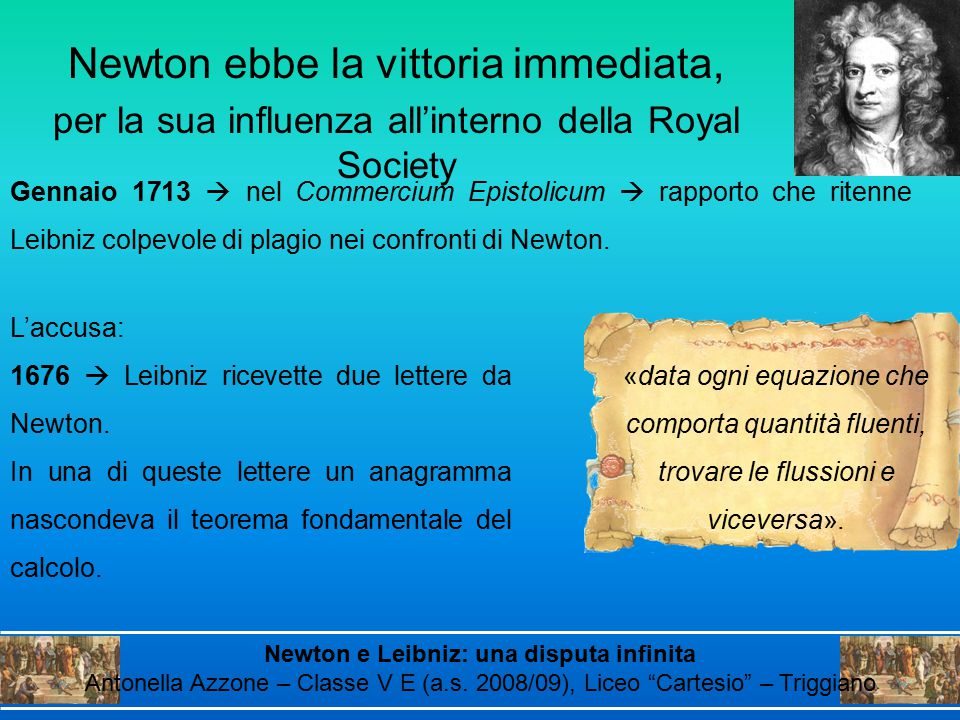What might be the historical significance of the anagram mentioned in the text, and how could it relate to the dispute between Newton and Leibniz? The anagram mentioned in the text holds significant historical importance in the context of the contentious debate over the invention of calculus between Isaac Newton and Gottfried Wilhelm Leibniz. In 1676, Newton sent Leibniz a letter containing an anagram that concealed a critical theorem of calculus. This practice was common in that era to establish intellectual priority without disclosing full details. Newton's anagram demonstrated that he had developed essential calculus concepts by 1676, earlier than Leibniz's published works. This became a pivotal point when the 'Commercium Epistolicum' report accused Leibniz of plagiarism, alleging he had access to Newton's ideas and used them to formulate his calculus theories. Thus, the anagram serves as a vital piece of evidence in understanding the rivalry and claims over the origins of calculus between these two mathematicians. 